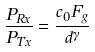Convert formula to latex. <formula><loc_0><loc_0><loc_500><loc_500>\frac { P _ { R x } } { P _ { T x } } = \frac { c _ { 0 } F _ { g } } { d ^ { \gamma } }</formula> 